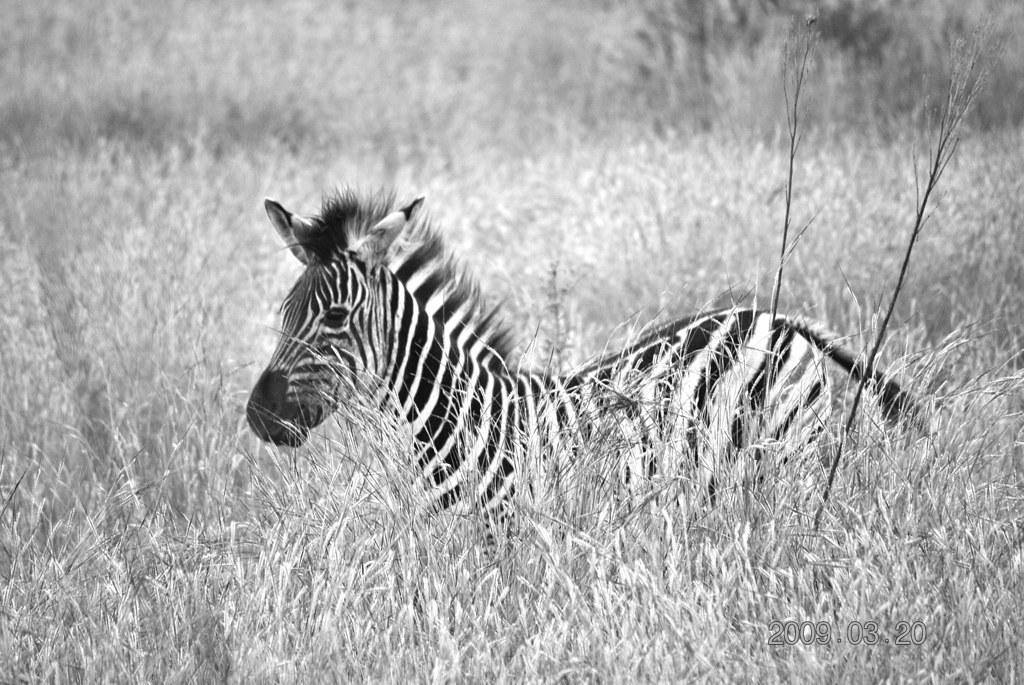What animal is the main subject of the image? There is a zebra in the image. Where is the zebra located in the image? The zebra is in the middle of the image. What type of vegetation can be seen in the background of the image? There is grass in the background of the image. What type of oatmeal is the zebra eating in the image? There is no oatmeal present in the image; the zebra is not shown eating anything. What appliance is being used by the zebra in the image? There is no appliance present in the image; the zebra is not shown using any tools or devices. 